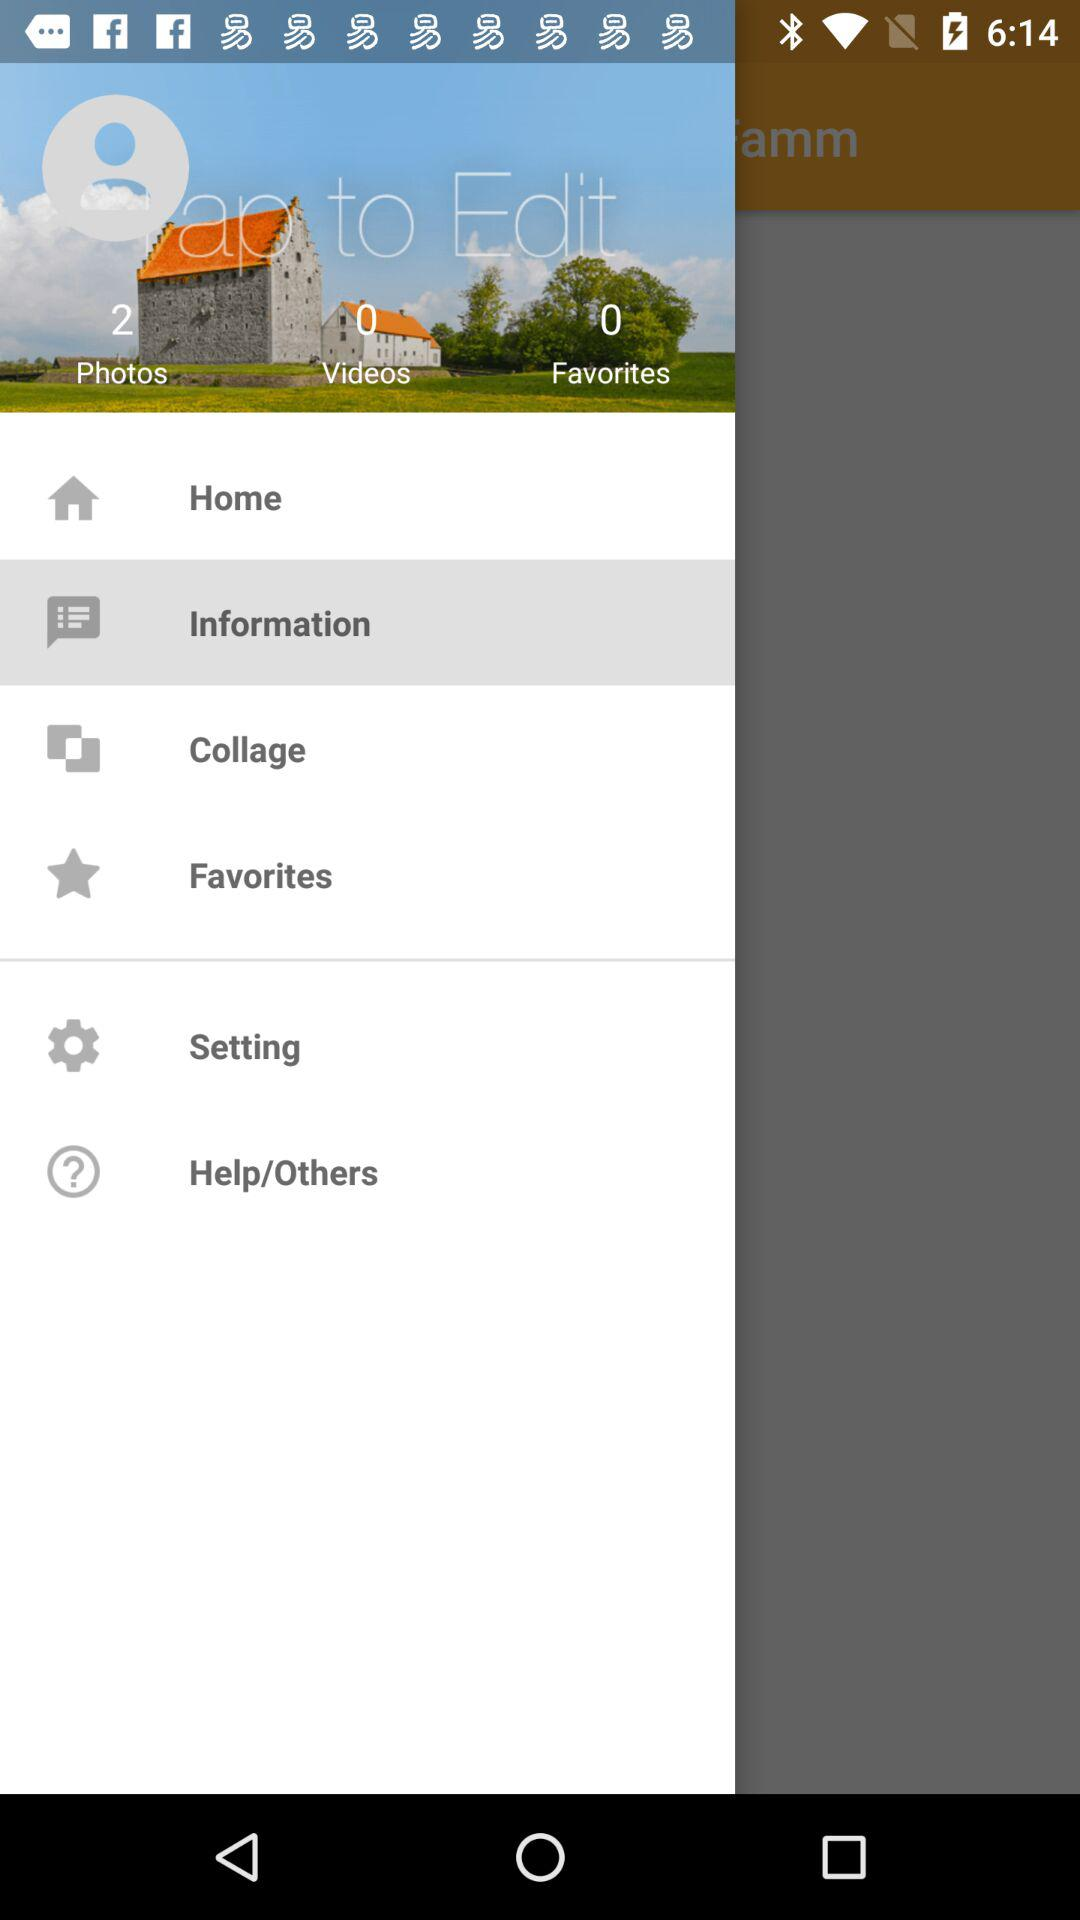What option is selected? The selected option is "Information". 